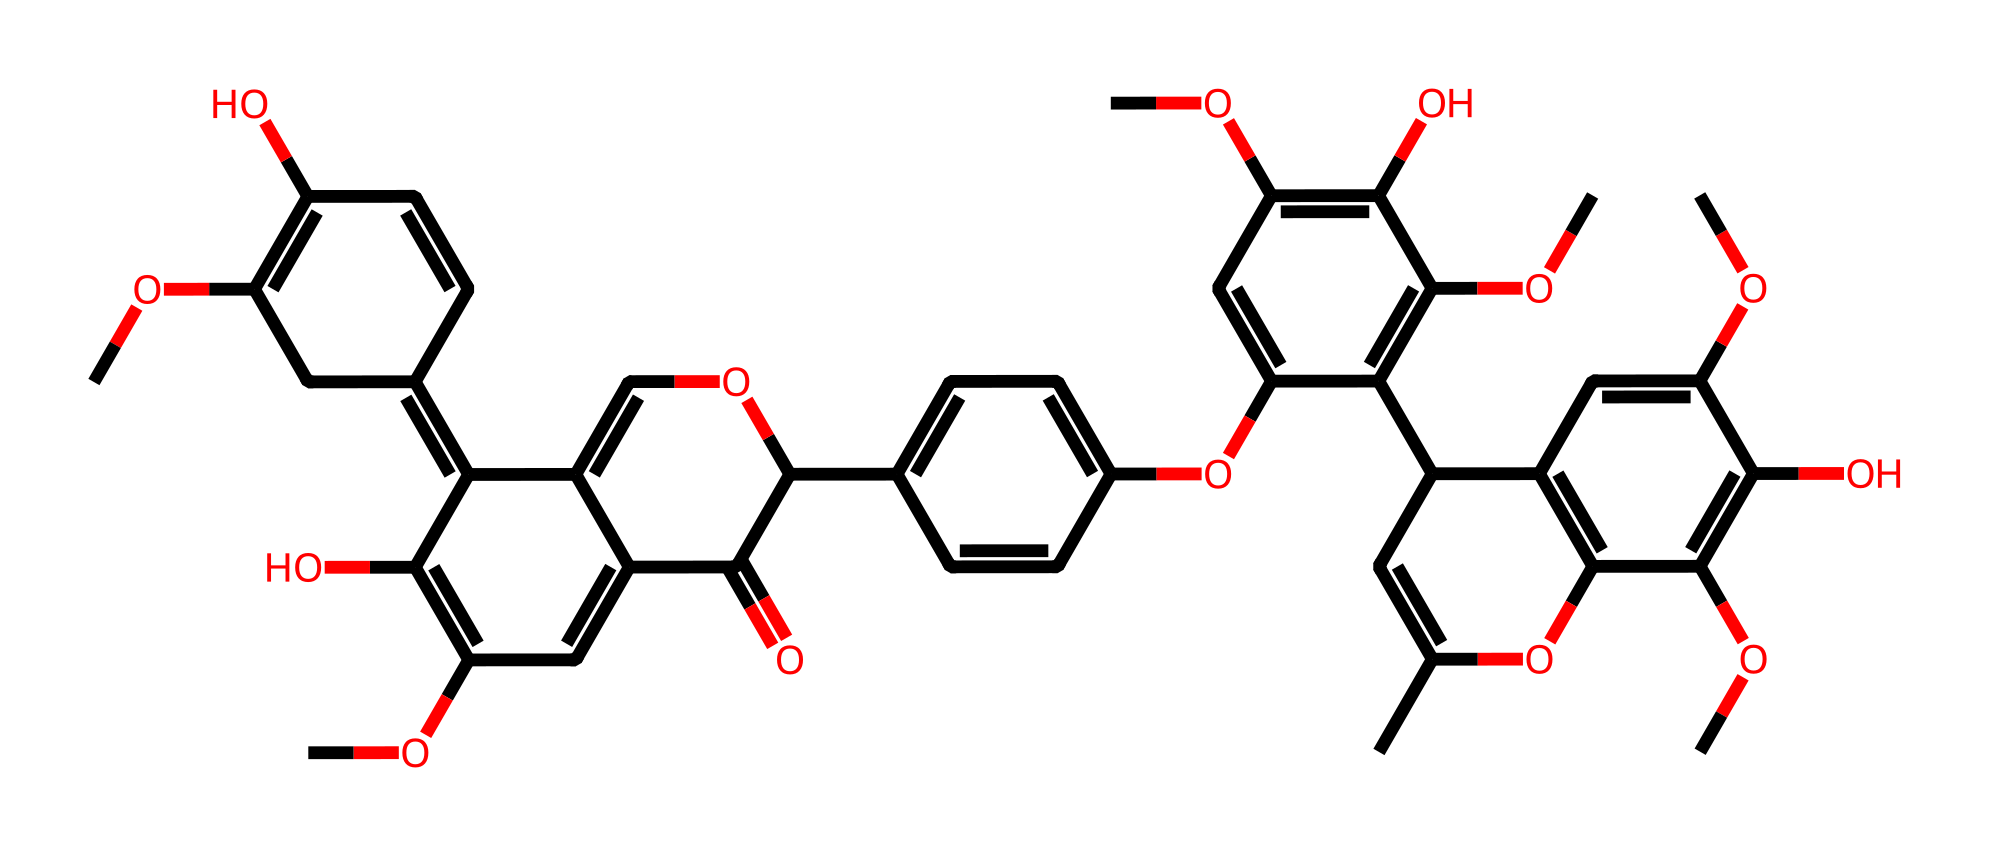How many carbon atoms are in this chemical? By analyzing the SMILES string, I count each "C" indicating a carbon atom. A careful tally reveals there are a total of 40 carbon atoms in the structure.
Answer: 40 What type of polymer is lignin classified as? Lignin is known as a phenolic polymer due to its structure containing phenolic units, which are characteristic of lignin's composition.
Answer: phenolic How many methoxy groups are present in this molecule? The term "OC" in the SMILES indicates a methoxy group. Counting the occurrences of "OC" in the structure yields a total of 9 methoxy groups.
Answer: 9 What type of bonding is primarily responsible for lignin's structural rigidity? The presence of covalent bonds between the phenolic units contributes to the rigidity of lignin's structure, allowing it to provide mechanical support in wood.
Answer: covalent Which part of this chemical contributes to its Non-Newtonian behavior? The complex network of interconnected phenolic residues and methoxy groups imparts the viscoelastic properties characteristic of Non-Newtonian fluids in lignin.
Answer: interconnected network 